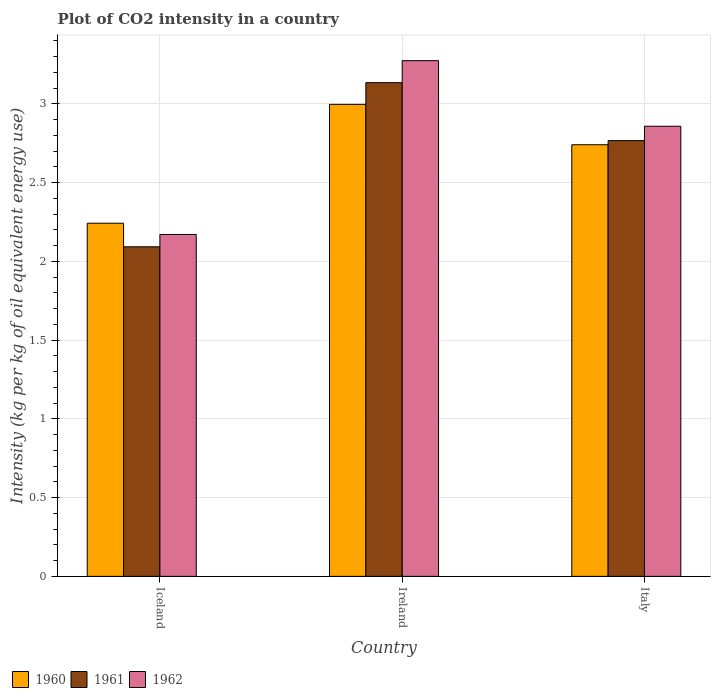Are the number of bars per tick equal to the number of legend labels?
Make the answer very short. Yes. What is the label of the 3rd group of bars from the left?
Ensure brevity in your answer.  Italy. What is the CO2 intensity in in 1962 in Iceland?
Provide a succinct answer. 2.17. Across all countries, what is the maximum CO2 intensity in in 1960?
Give a very brief answer. 3. Across all countries, what is the minimum CO2 intensity in in 1961?
Your answer should be compact. 2.09. In which country was the CO2 intensity in in 1962 maximum?
Provide a short and direct response. Ireland. What is the total CO2 intensity in in 1960 in the graph?
Ensure brevity in your answer.  7.98. What is the difference between the CO2 intensity in in 1961 in Iceland and that in Ireland?
Your answer should be compact. -1.04. What is the difference between the CO2 intensity in in 1961 in Ireland and the CO2 intensity in in 1962 in Iceland?
Provide a succinct answer. 0.96. What is the average CO2 intensity in in 1960 per country?
Your answer should be compact. 2.66. What is the difference between the CO2 intensity in of/in 1962 and CO2 intensity in of/in 1961 in Italy?
Your answer should be compact. 0.09. What is the ratio of the CO2 intensity in in 1962 in Iceland to that in Ireland?
Your response must be concise. 0.66. Is the CO2 intensity in in 1960 in Iceland less than that in Ireland?
Provide a short and direct response. Yes. What is the difference between the highest and the second highest CO2 intensity in in 1961?
Keep it short and to the point. -0.67. What is the difference between the highest and the lowest CO2 intensity in in 1961?
Provide a succinct answer. 1.04. In how many countries, is the CO2 intensity in in 1961 greater than the average CO2 intensity in in 1961 taken over all countries?
Offer a very short reply. 2. Is the sum of the CO2 intensity in in 1962 in Iceland and Ireland greater than the maximum CO2 intensity in in 1960 across all countries?
Keep it short and to the point. Yes. What does the 1st bar from the right in Ireland represents?
Ensure brevity in your answer.  1962. Are all the bars in the graph horizontal?
Provide a short and direct response. No. How many countries are there in the graph?
Your answer should be compact. 3. What is the difference between two consecutive major ticks on the Y-axis?
Provide a short and direct response. 0.5. Are the values on the major ticks of Y-axis written in scientific E-notation?
Provide a short and direct response. No. Does the graph contain any zero values?
Ensure brevity in your answer.  No. How many legend labels are there?
Your response must be concise. 3. What is the title of the graph?
Provide a succinct answer. Plot of CO2 intensity in a country. Does "1974" appear as one of the legend labels in the graph?
Your answer should be very brief. No. What is the label or title of the X-axis?
Ensure brevity in your answer.  Country. What is the label or title of the Y-axis?
Your answer should be compact. Intensity (kg per kg of oil equivalent energy use). What is the Intensity (kg per kg of oil equivalent energy use) in 1960 in Iceland?
Provide a succinct answer. 2.24. What is the Intensity (kg per kg of oil equivalent energy use) of 1961 in Iceland?
Make the answer very short. 2.09. What is the Intensity (kg per kg of oil equivalent energy use) of 1962 in Iceland?
Offer a terse response. 2.17. What is the Intensity (kg per kg of oil equivalent energy use) of 1960 in Ireland?
Provide a succinct answer. 3. What is the Intensity (kg per kg of oil equivalent energy use) of 1961 in Ireland?
Give a very brief answer. 3.14. What is the Intensity (kg per kg of oil equivalent energy use) of 1962 in Ireland?
Provide a short and direct response. 3.27. What is the Intensity (kg per kg of oil equivalent energy use) in 1960 in Italy?
Provide a succinct answer. 2.74. What is the Intensity (kg per kg of oil equivalent energy use) of 1961 in Italy?
Your response must be concise. 2.77. What is the Intensity (kg per kg of oil equivalent energy use) in 1962 in Italy?
Your response must be concise. 2.86. Across all countries, what is the maximum Intensity (kg per kg of oil equivalent energy use) of 1960?
Provide a succinct answer. 3. Across all countries, what is the maximum Intensity (kg per kg of oil equivalent energy use) in 1961?
Your answer should be compact. 3.14. Across all countries, what is the maximum Intensity (kg per kg of oil equivalent energy use) in 1962?
Provide a short and direct response. 3.27. Across all countries, what is the minimum Intensity (kg per kg of oil equivalent energy use) in 1960?
Keep it short and to the point. 2.24. Across all countries, what is the minimum Intensity (kg per kg of oil equivalent energy use) in 1961?
Offer a very short reply. 2.09. Across all countries, what is the minimum Intensity (kg per kg of oil equivalent energy use) of 1962?
Give a very brief answer. 2.17. What is the total Intensity (kg per kg of oil equivalent energy use) of 1960 in the graph?
Give a very brief answer. 7.98. What is the total Intensity (kg per kg of oil equivalent energy use) in 1961 in the graph?
Make the answer very short. 7.99. What is the total Intensity (kg per kg of oil equivalent energy use) in 1962 in the graph?
Make the answer very short. 8.3. What is the difference between the Intensity (kg per kg of oil equivalent energy use) of 1960 in Iceland and that in Ireland?
Offer a terse response. -0.75. What is the difference between the Intensity (kg per kg of oil equivalent energy use) in 1961 in Iceland and that in Ireland?
Give a very brief answer. -1.04. What is the difference between the Intensity (kg per kg of oil equivalent energy use) in 1962 in Iceland and that in Ireland?
Provide a succinct answer. -1.1. What is the difference between the Intensity (kg per kg of oil equivalent energy use) in 1960 in Iceland and that in Italy?
Make the answer very short. -0.5. What is the difference between the Intensity (kg per kg of oil equivalent energy use) of 1961 in Iceland and that in Italy?
Keep it short and to the point. -0.67. What is the difference between the Intensity (kg per kg of oil equivalent energy use) in 1962 in Iceland and that in Italy?
Your answer should be compact. -0.69. What is the difference between the Intensity (kg per kg of oil equivalent energy use) of 1960 in Ireland and that in Italy?
Provide a short and direct response. 0.26. What is the difference between the Intensity (kg per kg of oil equivalent energy use) in 1961 in Ireland and that in Italy?
Give a very brief answer. 0.37. What is the difference between the Intensity (kg per kg of oil equivalent energy use) of 1962 in Ireland and that in Italy?
Make the answer very short. 0.42. What is the difference between the Intensity (kg per kg of oil equivalent energy use) of 1960 in Iceland and the Intensity (kg per kg of oil equivalent energy use) of 1961 in Ireland?
Keep it short and to the point. -0.89. What is the difference between the Intensity (kg per kg of oil equivalent energy use) of 1960 in Iceland and the Intensity (kg per kg of oil equivalent energy use) of 1962 in Ireland?
Offer a very short reply. -1.03. What is the difference between the Intensity (kg per kg of oil equivalent energy use) in 1961 in Iceland and the Intensity (kg per kg of oil equivalent energy use) in 1962 in Ireland?
Offer a very short reply. -1.18. What is the difference between the Intensity (kg per kg of oil equivalent energy use) in 1960 in Iceland and the Intensity (kg per kg of oil equivalent energy use) in 1961 in Italy?
Your answer should be very brief. -0.52. What is the difference between the Intensity (kg per kg of oil equivalent energy use) in 1960 in Iceland and the Intensity (kg per kg of oil equivalent energy use) in 1962 in Italy?
Make the answer very short. -0.62. What is the difference between the Intensity (kg per kg of oil equivalent energy use) of 1961 in Iceland and the Intensity (kg per kg of oil equivalent energy use) of 1962 in Italy?
Keep it short and to the point. -0.77. What is the difference between the Intensity (kg per kg of oil equivalent energy use) in 1960 in Ireland and the Intensity (kg per kg of oil equivalent energy use) in 1961 in Italy?
Provide a short and direct response. 0.23. What is the difference between the Intensity (kg per kg of oil equivalent energy use) in 1960 in Ireland and the Intensity (kg per kg of oil equivalent energy use) in 1962 in Italy?
Provide a succinct answer. 0.14. What is the difference between the Intensity (kg per kg of oil equivalent energy use) of 1961 in Ireland and the Intensity (kg per kg of oil equivalent energy use) of 1962 in Italy?
Keep it short and to the point. 0.28. What is the average Intensity (kg per kg of oil equivalent energy use) of 1960 per country?
Ensure brevity in your answer.  2.66. What is the average Intensity (kg per kg of oil equivalent energy use) in 1961 per country?
Ensure brevity in your answer.  2.66. What is the average Intensity (kg per kg of oil equivalent energy use) in 1962 per country?
Your answer should be very brief. 2.77. What is the difference between the Intensity (kg per kg of oil equivalent energy use) in 1960 and Intensity (kg per kg of oil equivalent energy use) in 1961 in Iceland?
Provide a short and direct response. 0.15. What is the difference between the Intensity (kg per kg of oil equivalent energy use) in 1960 and Intensity (kg per kg of oil equivalent energy use) in 1962 in Iceland?
Make the answer very short. 0.07. What is the difference between the Intensity (kg per kg of oil equivalent energy use) of 1961 and Intensity (kg per kg of oil equivalent energy use) of 1962 in Iceland?
Your answer should be very brief. -0.08. What is the difference between the Intensity (kg per kg of oil equivalent energy use) in 1960 and Intensity (kg per kg of oil equivalent energy use) in 1961 in Ireland?
Your answer should be compact. -0.14. What is the difference between the Intensity (kg per kg of oil equivalent energy use) of 1960 and Intensity (kg per kg of oil equivalent energy use) of 1962 in Ireland?
Your answer should be compact. -0.28. What is the difference between the Intensity (kg per kg of oil equivalent energy use) of 1961 and Intensity (kg per kg of oil equivalent energy use) of 1962 in Ireland?
Provide a succinct answer. -0.14. What is the difference between the Intensity (kg per kg of oil equivalent energy use) in 1960 and Intensity (kg per kg of oil equivalent energy use) in 1961 in Italy?
Provide a succinct answer. -0.03. What is the difference between the Intensity (kg per kg of oil equivalent energy use) in 1960 and Intensity (kg per kg of oil equivalent energy use) in 1962 in Italy?
Provide a succinct answer. -0.12. What is the difference between the Intensity (kg per kg of oil equivalent energy use) of 1961 and Intensity (kg per kg of oil equivalent energy use) of 1962 in Italy?
Provide a short and direct response. -0.09. What is the ratio of the Intensity (kg per kg of oil equivalent energy use) of 1960 in Iceland to that in Ireland?
Make the answer very short. 0.75. What is the ratio of the Intensity (kg per kg of oil equivalent energy use) of 1961 in Iceland to that in Ireland?
Give a very brief answer. 0.67. What is the ratio of the Intensity (kg per kg of oil equivalent energy use) in 1962 in Iceland to that in Ireland?
Your answer should be compact. 0.66. What is the ratio of the Intensity (kg per kg of oil equivalent energy use) in 1960 in Iceland to that in Italy?
Ensure brevity in your answer.  0.82. What is the ratio of the Intensity (kg per kg of oil equivalent energy use) of 1961 in Iceland to that in Italy?
Provide a succinct answer. 0.76. What is the ratio of the Intensity (kg per kg of oil equivalent energy use) of 1962 in Iceland to that in Italy?
Offer a terse response. 0.76. What is the ratio of the Intensity (kg per kg of oil equivalent energy use) in 1960 in Ireland to that in Italy?
Your answer should be compact. 1.09. What is the ratio of the Intensity (kg per kg of oil equivalent energy use) in 1961 in Ireland to that in Italy?
Make the answer very short. 1.13. What is the ratio of the Intensity (kg per kg of oil equivalent energy use) in 1962 in Ireland to that in Italy?
Provide a succinct answer. 1.15. What is the difference between the highest and the second highest Intensity (kg per kg of oil equivalent energy use) in 1960?
Provide a short and direct response. 0.26. What is the difference between the highest and the second highest Intensity (kg per kg of oil equivalent energy use) in 1961?
Offer a terse response. 0.37. What is the difference between the highest and the second highest Intensity (kg per kg of oil equivalent energy use) of 1962?
Provide a succinct answer. 0.42. What is the difference between the highest and the lowest Intensity (kg per kg of oil equivalent energy use) of 1960?
Provide a succinct answer. 0.75. What is the difference between the highest and the lowest Intensity (kg per kg of oil equivalent energy use) of 1961?
Offer a very short reply. 1.04. What is the difference between the highest and the lowest Intensity (kg per kg of oil equivalent energy use) of 1962?
Provide a succinct answer. 1.1. 